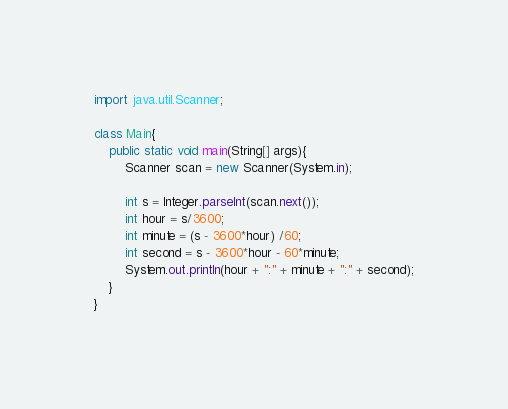Convert code to text. <code><loc_0><loc_0><loc_500><loc_500><_Java_>import java.util.Scanner;

class Main{
    public static void main(String[] args){
        Scanner scan = new Scanner(System.in);

        int s = Integer.parseInt(scan.next());
        int hour = s/3600;
        int minute = (s - 3600*hour) /60;
        int second = s - 3600*hour - 60*minute;
        System.out.println(hour + ":" + minute + ":" + second);
    }
}</code> 